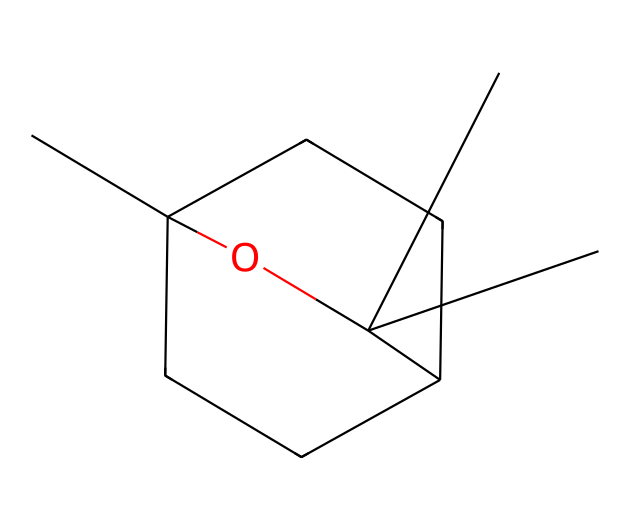What is the name of this chemical? The provided SMILES represents eucalyptol, a colorless, flammable liquid component found in certain essential oils.
Answer: eucalyptol How many carbon atoms are in the structure? By analyzing the SMILES, we can count the number of carbon atoms present in the structure, which appear as 'C' in the notation. There are 10 carbon atoms.
Answer: 10 What is the functional group present in this molecule? The '-O-' represents an alcohol functional group present in the structure, indicating that it is a type of alcohol.
Answer: alcohol How many rings are present in the structure? The number '1' and '2' in the SMILES indicate the presence of two cyclic structures or rings in the arrangement.
Answer: 2 What type of chemical is eucalyptol classified as? Eucalyptol is classified as a monoterpenoid due to its structure featuring a cyclic arrangement and is derived from terpenes.
Answer: monoterpenoid Does this chemical have a high boiling point? Eucalyptol, being a small molecule and due to its molecular structure, has a boiling point around 176 °C, which is relatively moderate, indicating it does not have a high boiling point.
Answer: no Why is eucalyptol used in medicinal balms? Eucalyptol has been associated with soothing properties and can act as an anti-inflammatory agent, making it suitable for use in medicinal balms.
Answer: soothing properties 